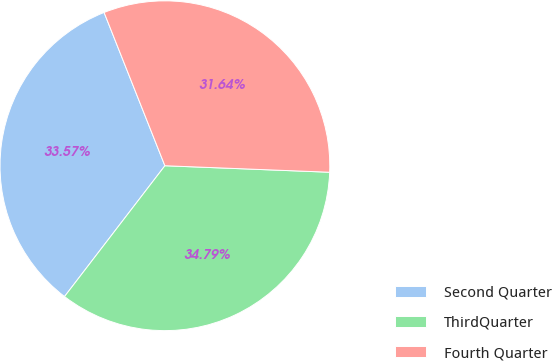Convert chart. <chart><loc_0><loc_0><loc_500><loc_500><pie_chart><fcel>Second Quarter<fcel>ThirdQuarter<fcel>Fourth Quarter<nl><fcel>33.57%<fcel>34.79%<fcel>31.64%<nl></chart> 